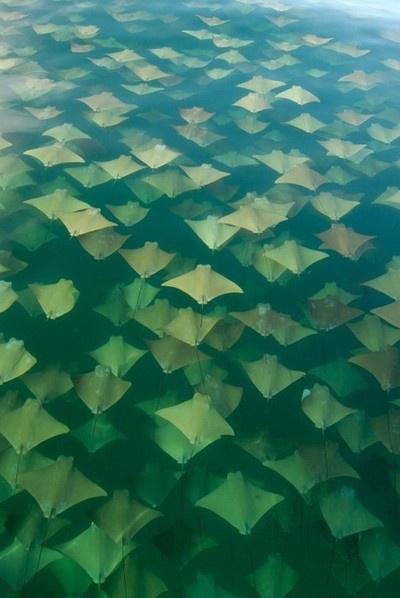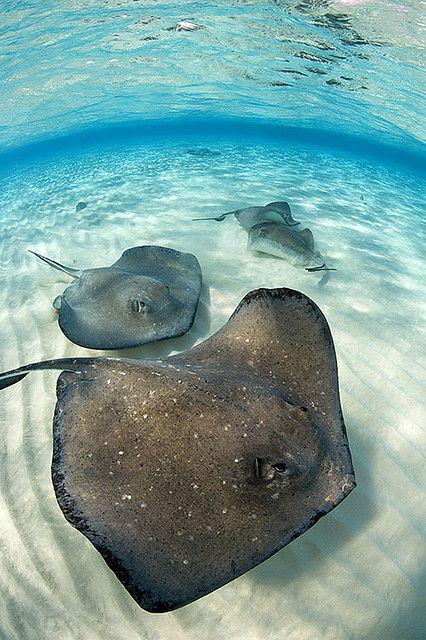The first image is the image on the left, the second image is the image on the right. Considering the images on both sides, is "the left image shows a sea full of stingray from the top view" valid? Answer yes or no. Yes. The first image is the image on the left, the second image is the image on the right. Evaluate the accuracy of this statement regarding the images: "At least one image in the pair shows a single stingray.". Is it true? Answer yes or no. No. 